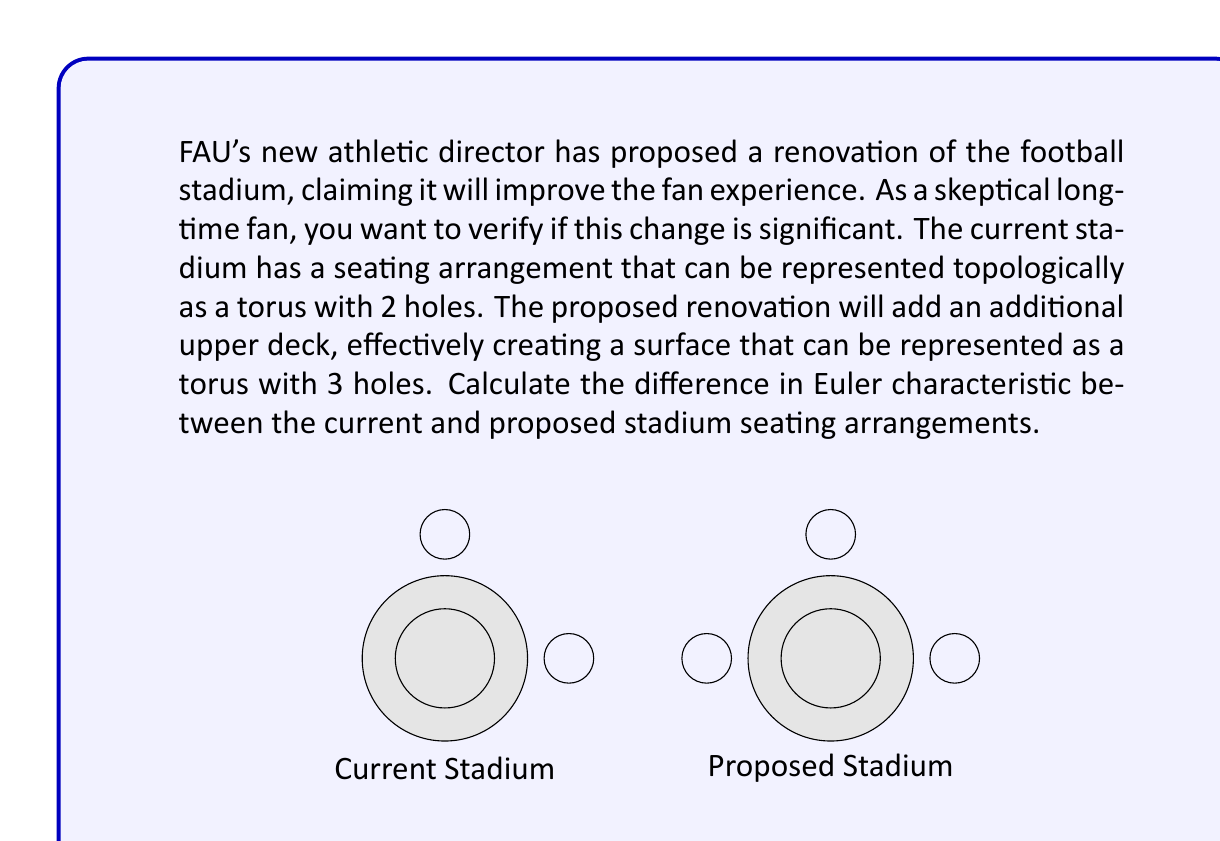Provide a solution to this math problem. Let's approach this step-by-step:

1) The Euler characteristic $\chi$ of a surface is given by the formula:

   $$\chi = 2 - 2g$$

   where $g$ is the genus (number of holes) of the surface.

2) For the current stadium (torus with 2 holes):
   $g_1 = 2$
   $$\chi_1 = 2 - 2(2) = 2 - 4 = -2$$

3) For the proposed stadium (torus with 3 holes):
   $g_2 = 3$
   $$\chi_2 = 2 - 2(3) = 2 - 6 = -4$$

4) The difference in Euler characteristic is:
   $$\Delta \chi = \chi_2 - \chi_1 = -4 - (-2) = -2$$

Therefore, the difference in Euler characteristic between the current and proposed stadium seating arrangements is -2.
Answer: $-2$ 